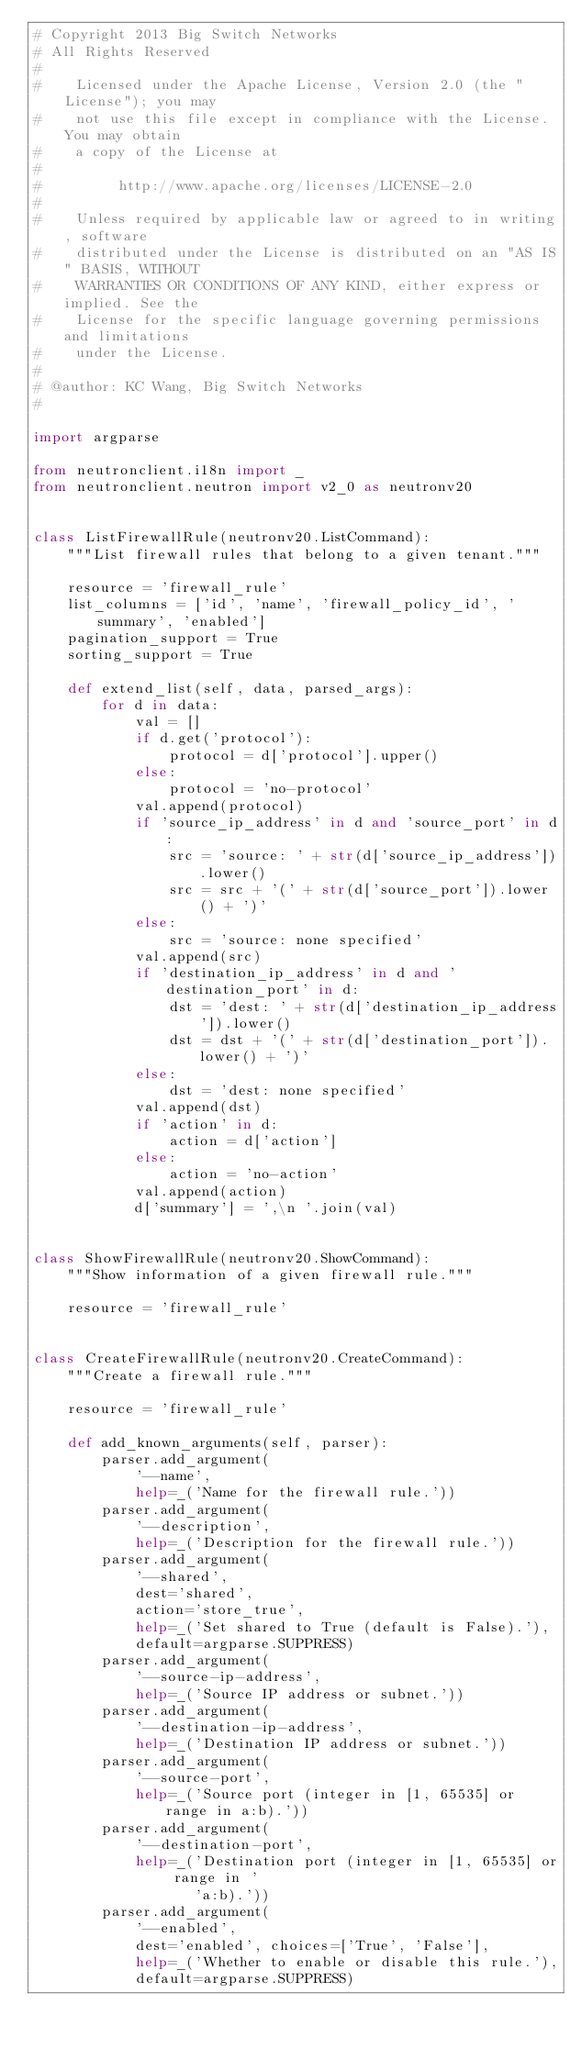Convert code to text. <code><loc_0><loc_0><loc_500><loc_500><_Python_># Copyright 2013 Big Switch Networks
# All Rights Reserved
#
#    Licensed under the Apache License, Version 2.0 (the "License"); you may
#    not use this file except in compliance with the License. You may obtain
#    a copy of the License at
#
#         http://www.apache.org/licenses/LICENSE-2.0
#
#    Unless required by applicable law or agreed to in writing, software
#    distributed under the License is distributed on an "AS IS" BASIS, WITHOUT
#    WARRANTIES OR CONDITIONS OF ANY KIND, either express or implied. See the
#    License for the specific language governing permissions and limitations
#    under the License.
#
# @author: KC Wang, Big Switch Networks
#

import argparse

from neutronclient.i18n import _
from neutronclient.neutron import v2_0 as neutronv20


class ListFirewallRule(neutronv20.ListCommand):
    """List firewall rules that belong to a given tenant."""

    resource = 'firewall_rule'
    list_columns = ['id', 'name', 'firewall_policy_id', 'summary', 'enabled']
    pagination_support = True
    sorting_support = True

    def extend_list(self, data, parsed_args):
        for d in data:
            val = []
            if d.get('protocol'):
                protocol = d['protocol'].upper()
            else:
                protocol = 'no-protocol'
            val.append(protocol)
            if 'source_ip_address' in d and 'source_port' in d:
                src = 'source: ' + str(d['source_ip_address']).lower()
                src = src + '(' + str(d['source_port']).lower() + ')'
            else:
                src = 'source: none specified'
            val.append(src)
            if 'destination_ip_address' in d and 'destination_port' in d:
                dst = 'dest: ' + str(d['destination_ip_address']).lower()
                dst = dst + '(' + str(d['destination_port']).lower() + ')'
            else:
                dst = 'dest: none specified'
            val.append(dst)
            if 'action' in d:
                action = d['action']
            else:
                action = 'no-action'
            val.append(action)
            d['summary'] = ',\n '.join(val)


class ShowFirewallRule(neutronv20.ShowCommand):
    """Show information of a given firewall rule."""

    resource = 'firewall_rule'


class CreateFirewallRule(neutronv20.CreateCommand):
    """Create a firewall rule."""

    resource = 'firewall_rule'

    def add_known_arguments(self, parser):
        parser.add_argument(
            '--name',
            help=_('Name for the firewall rule.'))
        parser.add_argument(
            '--description',
            help=_('Description for the firewall rule.'))
        parser.add_argument(
            '--shared',
            dest='shared',
            action='store_true',
            help=_('Set shared to True (default is False).'),
            default=argparse.SUPPRESS)
        parser.add_argument(
            '--source-ip-address',
            help=_('Source IP address or subnet.'))
        parser.add_argument(
            '--destination-ip-address',
            help=_('Destination IP address or subnet.'))
        parser.add_argument(
            '--source-port',
            help=_('Source port (integer in [1, 65535] or range in a:b).'))
        parser.add_argument(
            '--destination-port',
            help=_('Destination port (integer in [1, 65535] or range in '
                   'a:b).'))
        parser.add_argument(
            '--enabled',
            dest='enabled', choices=['True', 'False'],
            help=_('Whether to enable or disable this rule.'),
            default=argparse.SUPPRESS)</code> 